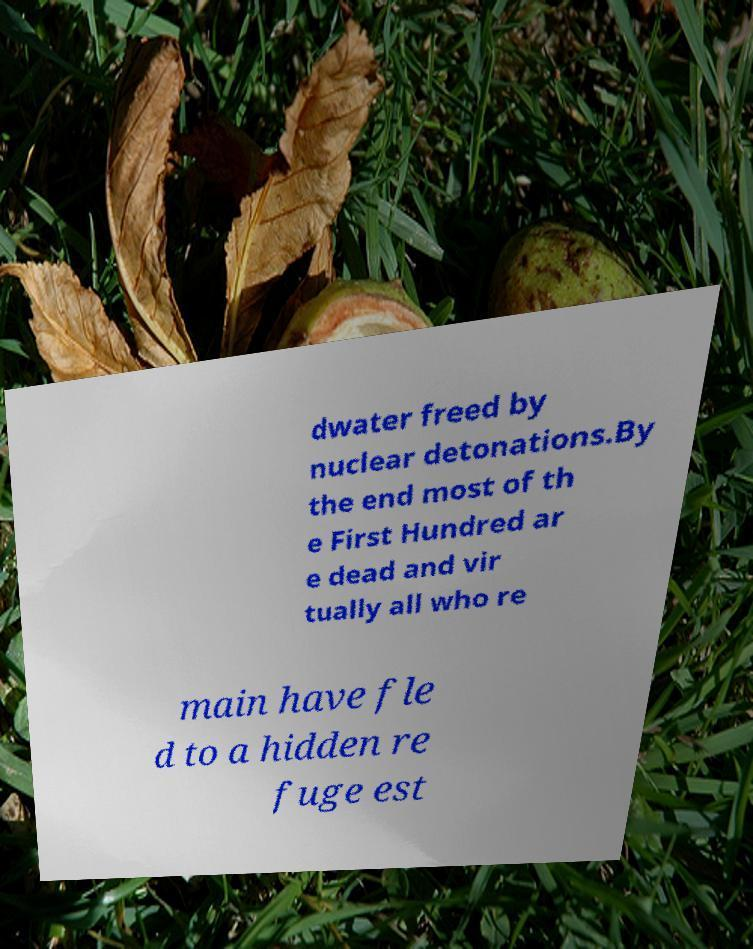Please identify and transcribe the text found in this image. dwater freed by nuclear detonations.By the end most of th e First Hundred ar e dead and vir tually all who re main have fle d to a hidden re fuge est 